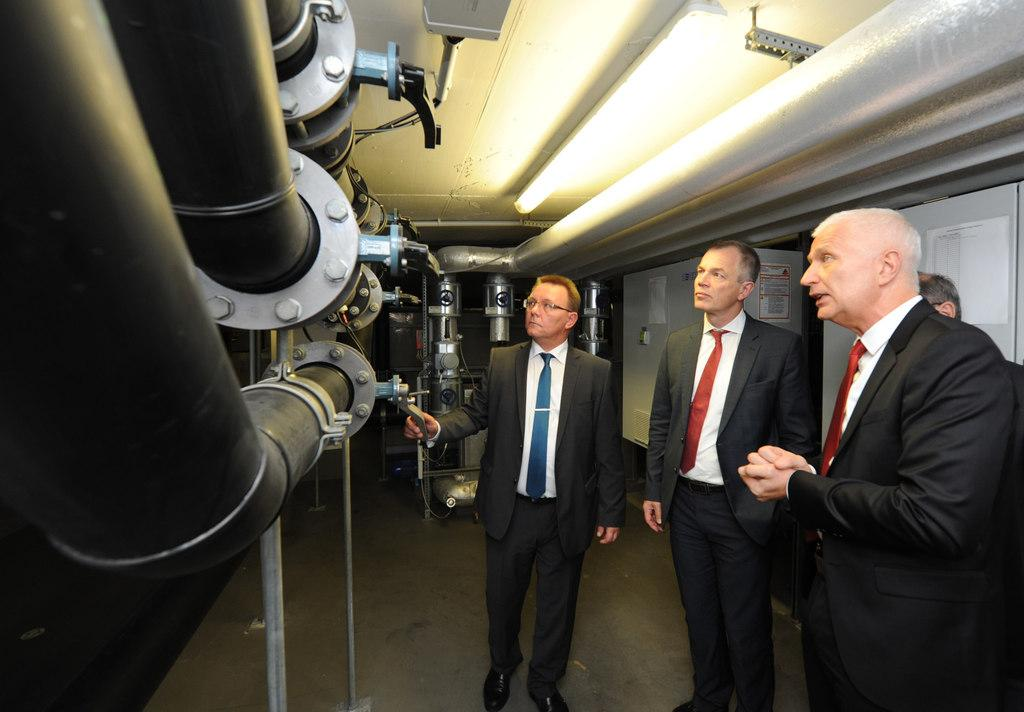How many people are in the image? There are four members in the image. What are three of the members wearing? Three of the members are wearing coats. What can be seen on the left side of the image? There are large pipelines on the left side of the image. Is there a volcano visible in the image? No, there is no volcano present in the image. Can you purchase a ticket for the pipelines in the image? The image does not depict any ticket-related activities or structures. 